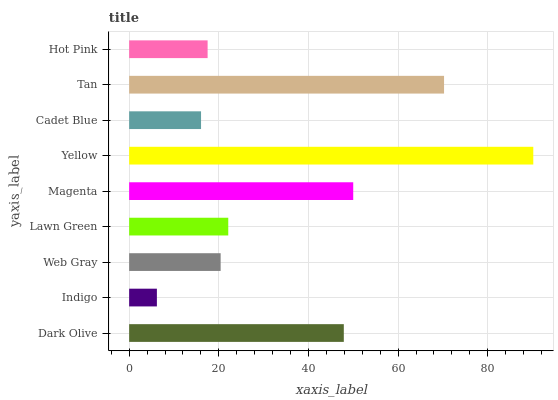Is Indigo the minimum?
Answer yes or no. Yes. Is Yellow the maximum?
Answer yes or no. Yes. Is Web Gray the minimum?
Answer yes or no. No. Is Web Gray the maximum?
Answer yes or no. No. Is Web Gray greater than Indigo?
Answer yes or no. Yes. Is Indigo less than Web Gray?
Answer yes or no. Yes. Is Indigo greater than Web Gray?
Answer yes or no. No. Is Web Gray less than Indigo?
Answer yes or no. No. Is Lawn Green the high median?
Answer yes or no. Yes. Is Lawn Green the low median?
Answer yes or no. Yes. Is Tan the high median?
Answer yes or no. No. Is Yellow the low median?
Answer yes or no. No. 